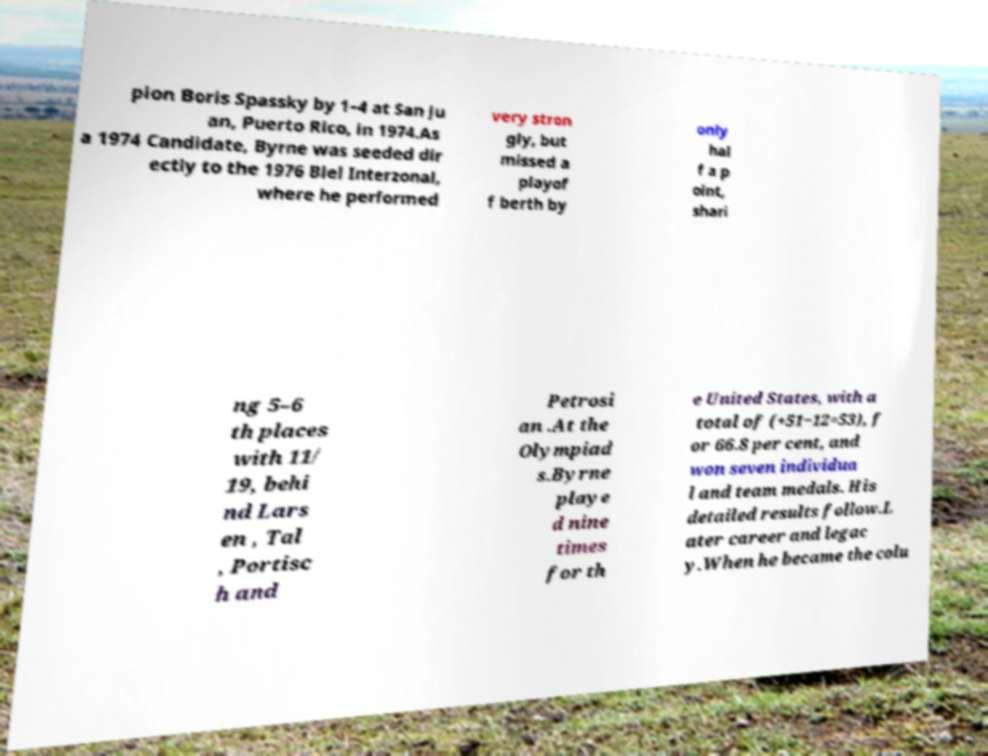Could you extract and type out the text from this image? pion Boris Spassky by 1–4 at San Ju an, Puerto Rico, in 1974.As a 1974 Candidate, Byrne was seeded dir ectly to the 1976 Biel Interzonal, where he performed very stron gly, but missed a playof f berth by only hal f a p oint, shari ng 5–6 th places with 11/ 19, behi nd Lars en , Tal , Portisc h and Petrosi an .At the Olympiad s.Byrne playe d nine times for th e United States, with a total of (+51−12=53), f or 66.8 per cent, and won seven individua l and team medals. His detailed results follow.L ater career and legac y.When he became the colu 